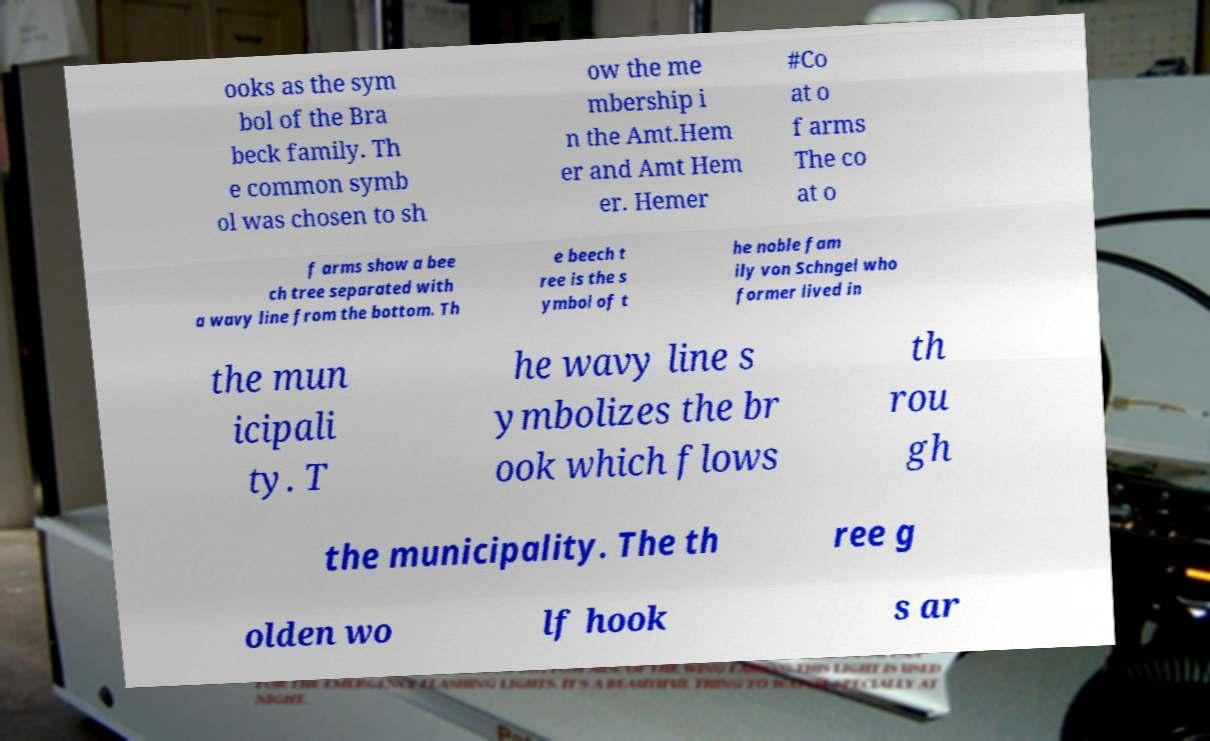Could you extract and type out the text from this image? ooks as the sym bol of the Bra beck family. Th e common symb ol was chosen to sh ow the me mbership i n the Amt.Hem er and Amt Hem er. Hemer #Co at o f arms The co at o f arms show a bee ch tree separated with a wavy line from the bottom. Th e beech t ree is the s ymbol of t he noble fam ily von Schngel who former lived in the mun icipali ty. T he wavy line s ymbolizes the br ook which flows th rou gh the municipality. The th ree g olden wo lf hook s ar 